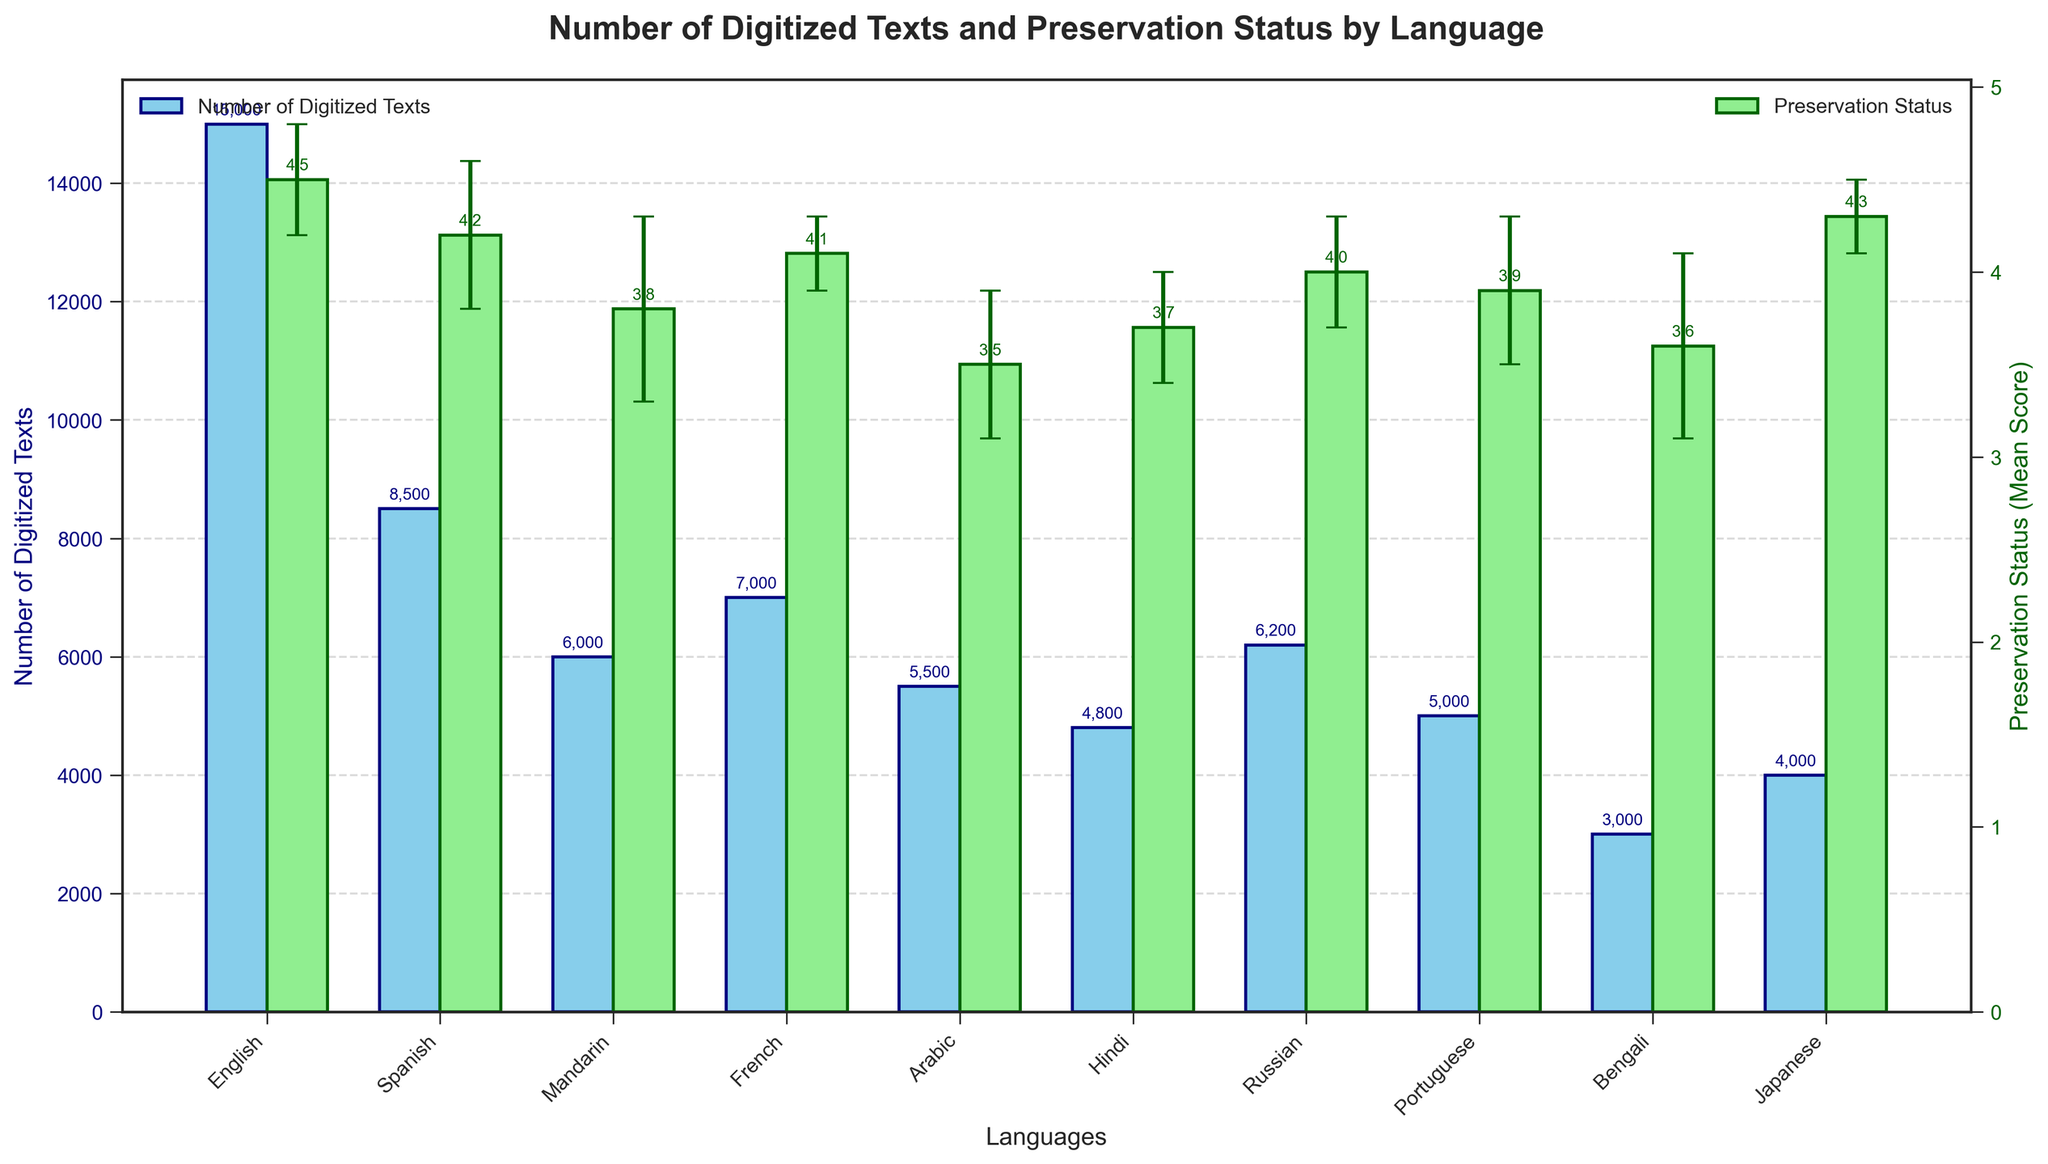What is the title of the figure? The title is the large, bold text at the top of the figure. It summarizes the primary content and purpose of the chart.
Answer: Number of Digitized Texts and Preservation Status by Language What is the language with the highest number of digitized texts? Look at the bar representing "Number of Digitized Texts" for each language. The tallest bar represents the highest number.
Answer: English How many digitized texts are there for Spanish? Identify the bar labeled "Spanish" on the x-axis and look at its height. It’s annotated with the exact number.
Answer: 8,500 Which language has the highest preservation status mean score? Compare the bars representing "Preservation Status (Mean Score)" for each language. The tallest bar indicates the highest mean score.
Answer: English What is the difference in the preservation status mean score between Mandarin and Arabic? Find the height of the bars for Mandarin and Arabic for the "Preservation Status (Mean Score)." Subtract the mean score for Arabic from the mean score for Mandarin.
Answer: 0.3 Which two languages have the closest number of digitized texts? Look for bars that have nearly the same height for "Number of Digitized Texts."
Answer: Russian and Mandarin What is the approximate preservation status mean score for French, and what is its error margin? Look at the height of the bar for French under "Preservation Status (Mean Score)" and note the error bars at the top of the bar which indicate the error margin.
Answer: 4.1, 0.2 If the preservation status mean score of English is reduced by 0.3, what would be the new mean score? Subtract 0.3 from the current mean score of English.
Answer: 4.2 Compare the preservation status mean scores of Russian and Japanese. Which is higher? Compare the heights of the bars for Russian and Japanese under "Preservation Status (Mean Score)."
Answer: Japanese Calculate the average number of digitized texts for French, Arabic, and Portuguese. Add the number of digitized texts for French (7000), Arabic (5500), and Portuguese (5000), then divide by 3 to get the average.
Answer: 5,833⅓ 